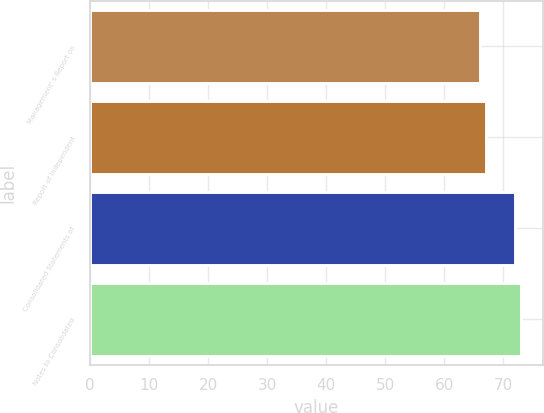Convert chart. <chart><loc_0><loc_0><loc_500><loc_500><bar_chart><fcel>Management' s Report on<fcel>Report of Independent<fcel>Consolidated Statements of<fcel>Notes to Consolidated<nl><fcel>66<fcel>67<fcel>72<fcel>73<nl></chart> 